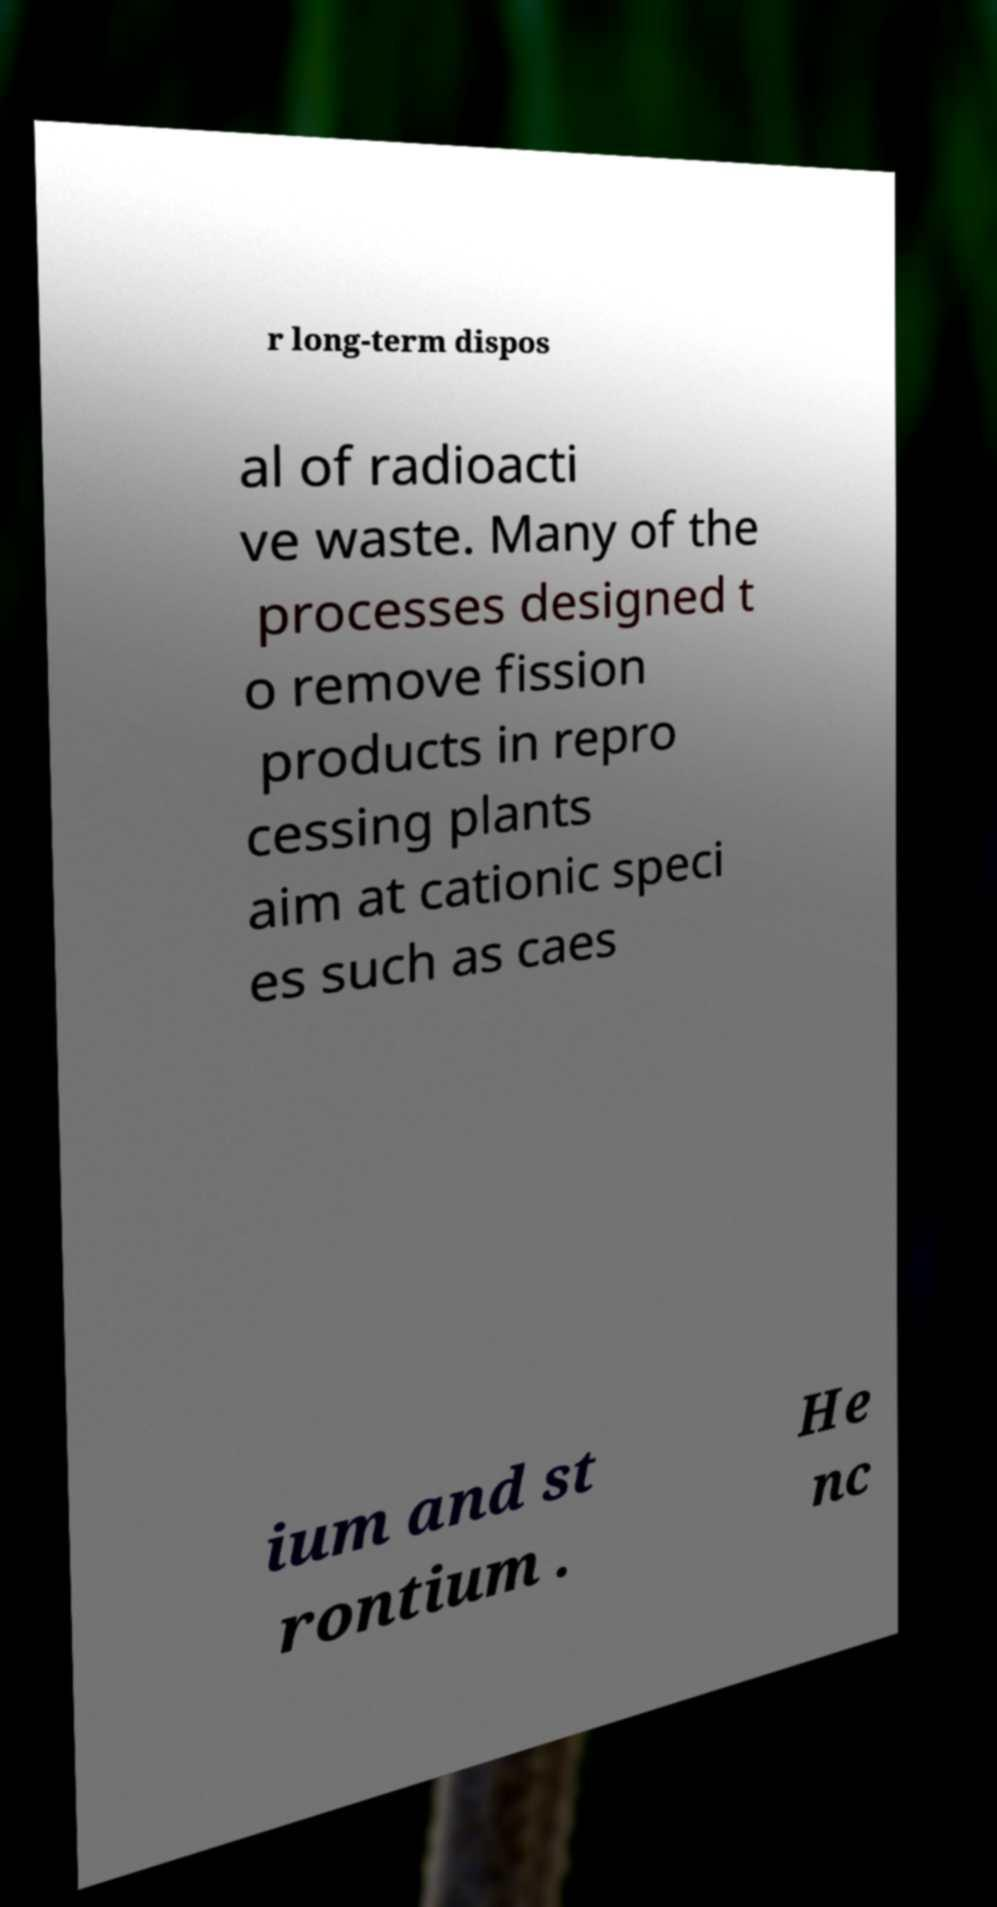Please read and relay the text visible in this image. What does it say? r long-term dispos al of radioacti ve waste. Many of the processes designed t o remove fission products in repro cessing plants aim at cationic speci es such as caes ium and st rontium . He nc 